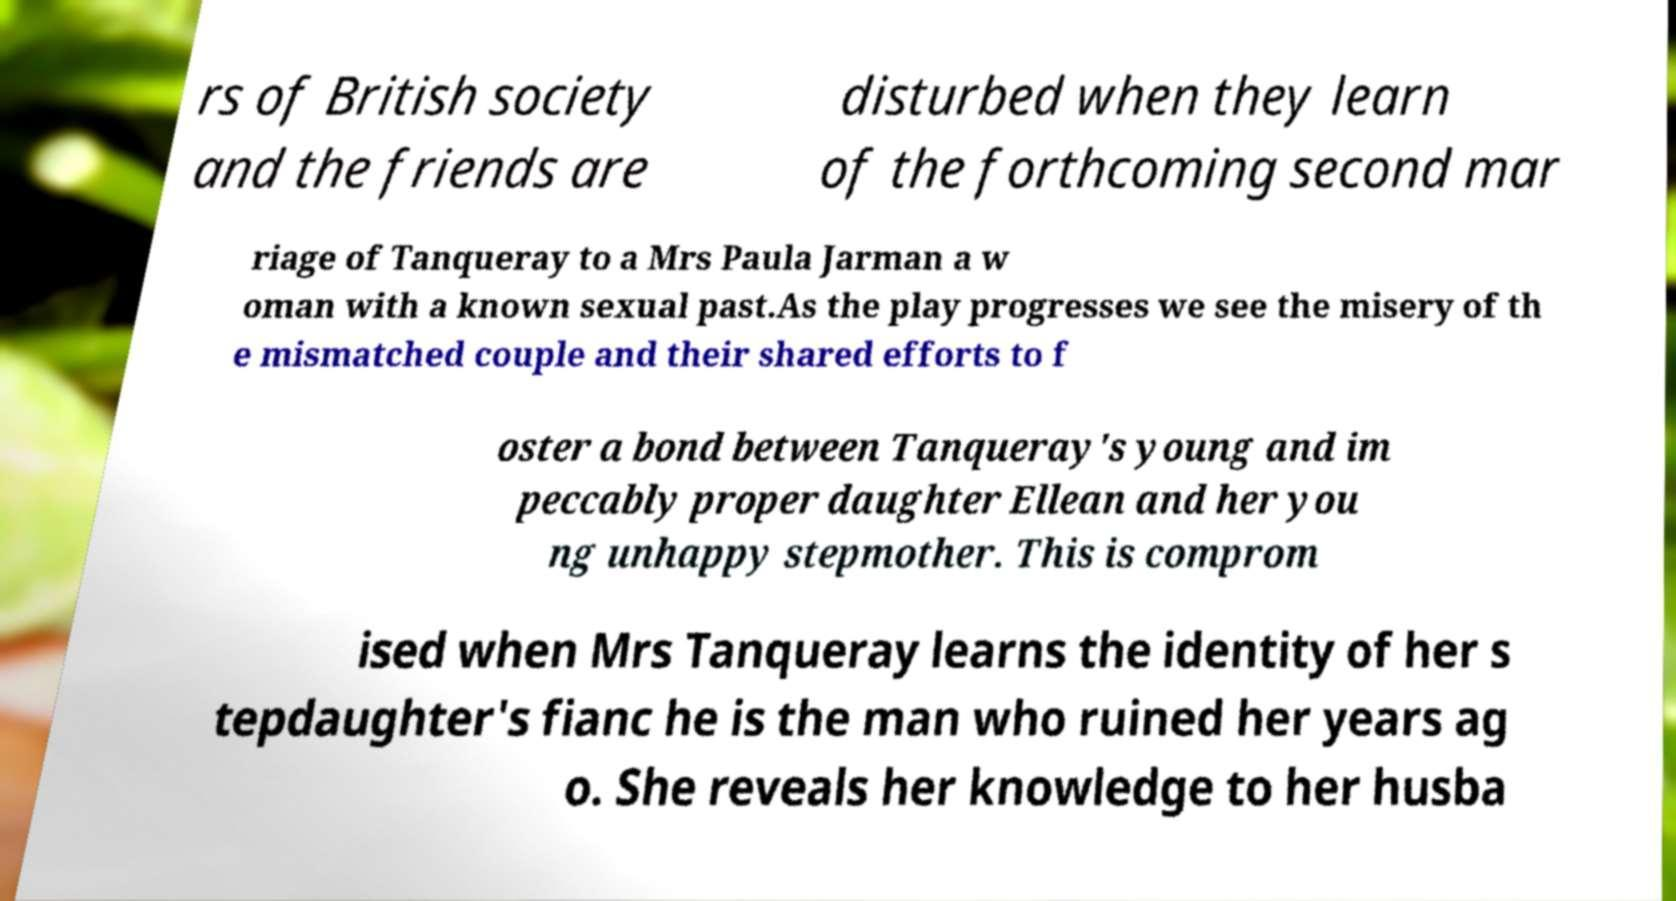Please identify and transcribe the text found in this image. rs of British society and the friends are disturbed when they learn of the forthcoming second mar riage of Tanqueray to a Mrs Paula Jarman a w oman with a known sexual past.As the play progresses we see the misery of th e mismatched couple and their shared efforts to f oster a bond between Tanqueray's young and im peccably proper daughter Ellean and her you ng unhappy stepmother. This is comprom ised when Mrs Tanqueray learns the identity of her s tepdaughter's fianc he is the man who ruined her years ag o. She reveals her knowledge to her husba 